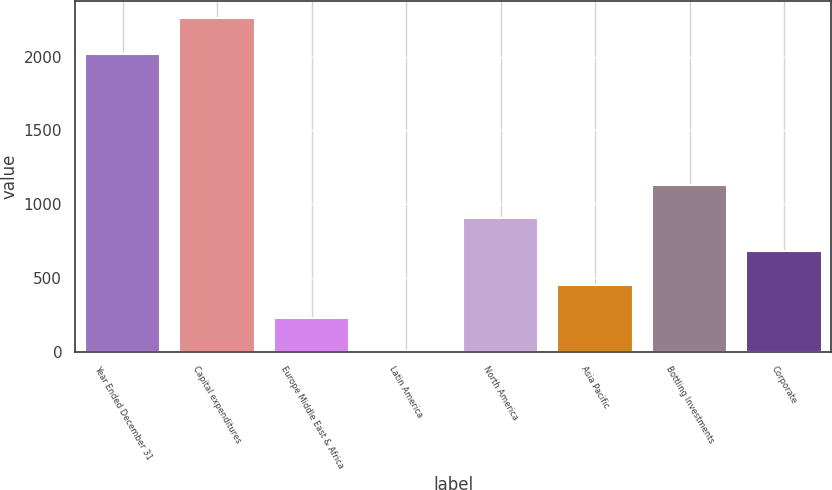Convert chart. <chart><loc_0><loc_0><loc_500><loc_500><bar_chart><fcel>Year Ended December 31<fcel>Capital expenditures<fcel>Europe Middle East & Africa<fcel>Latin America<fcel>North America<fcel>Asia Pacific<fcel>Bottling Investments<fcel>Corporate<nl><fcel>2016<fcel>2262<fcel>228<fcel>2<fcel>906<fcel>454<fcel>1132<fcel>680<nl></chart> 